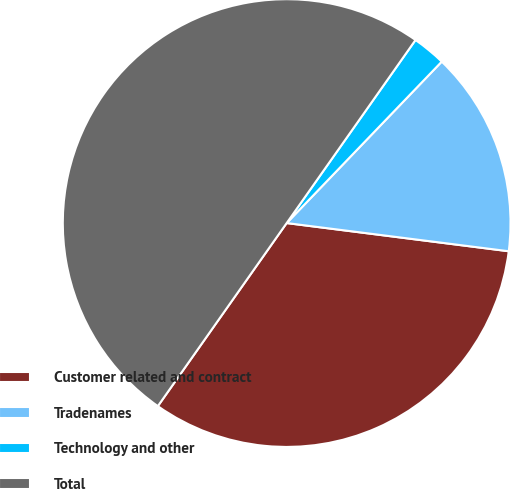Convert chart to OTSL. <chart><loc_0><loc_0><loc_500><loc_500><pie_chart><fcel>Customer related and contract<fcel>Tradenames<fcel>Technology and other<fcel>Total<nl><fcel>32.75%<fcel>14.83%<fcel>2.42%<fcel>50.0%<nl></chart> 